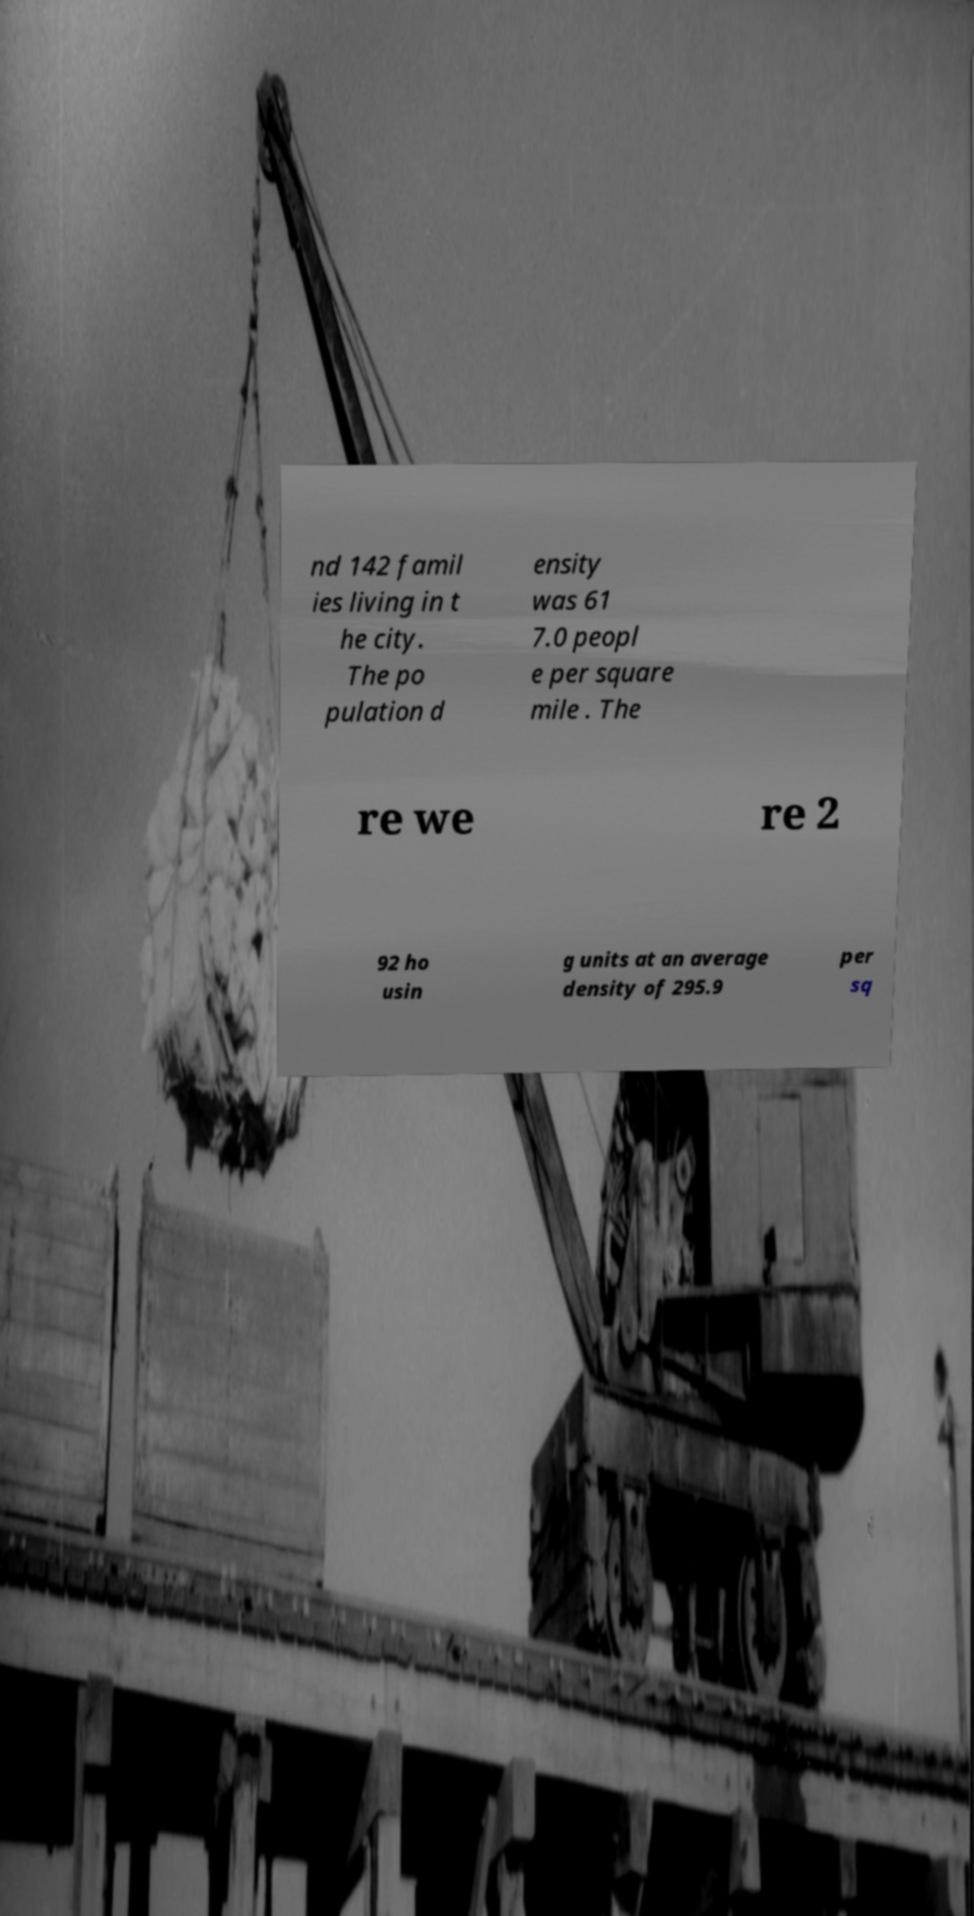Please read and relay the text visible in this image. What does it say? nd 142 famil ies living in t he city. The po pulation d ensity was 61 7.0 peopl e per square mile . The re we re 2 92 ho usin g units at an average density of 295.9 per sq 